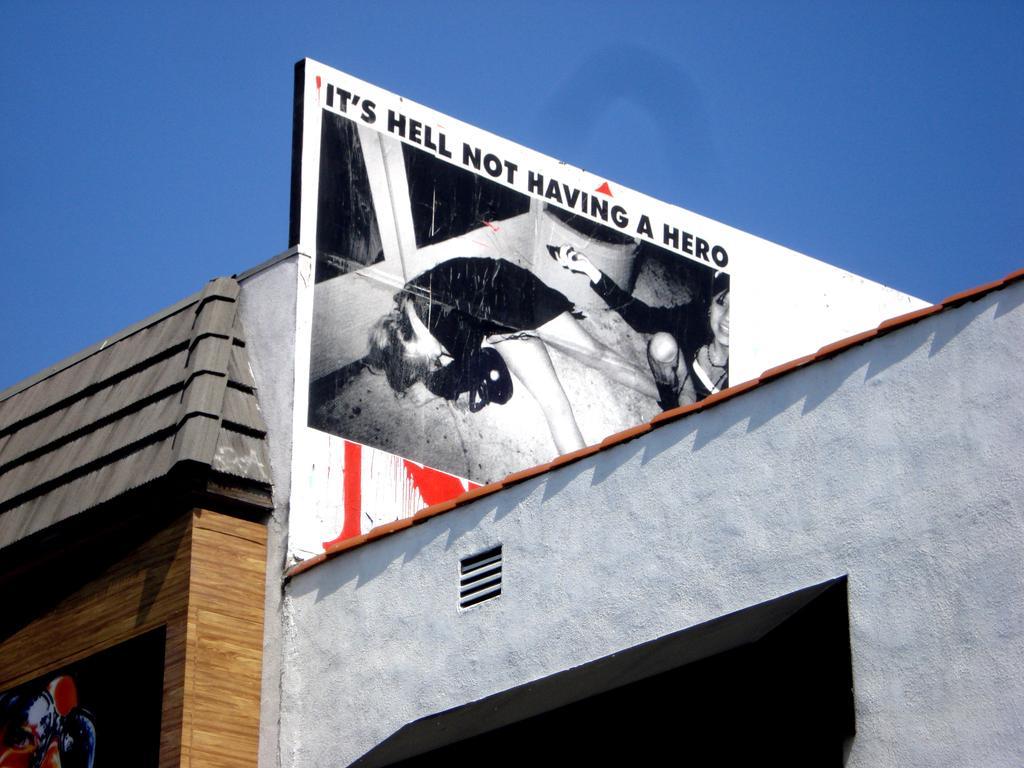Please provide a concise description of this image. In this picture I can see a building, there are two posters on the walls of the building, and in the background there is sky. 